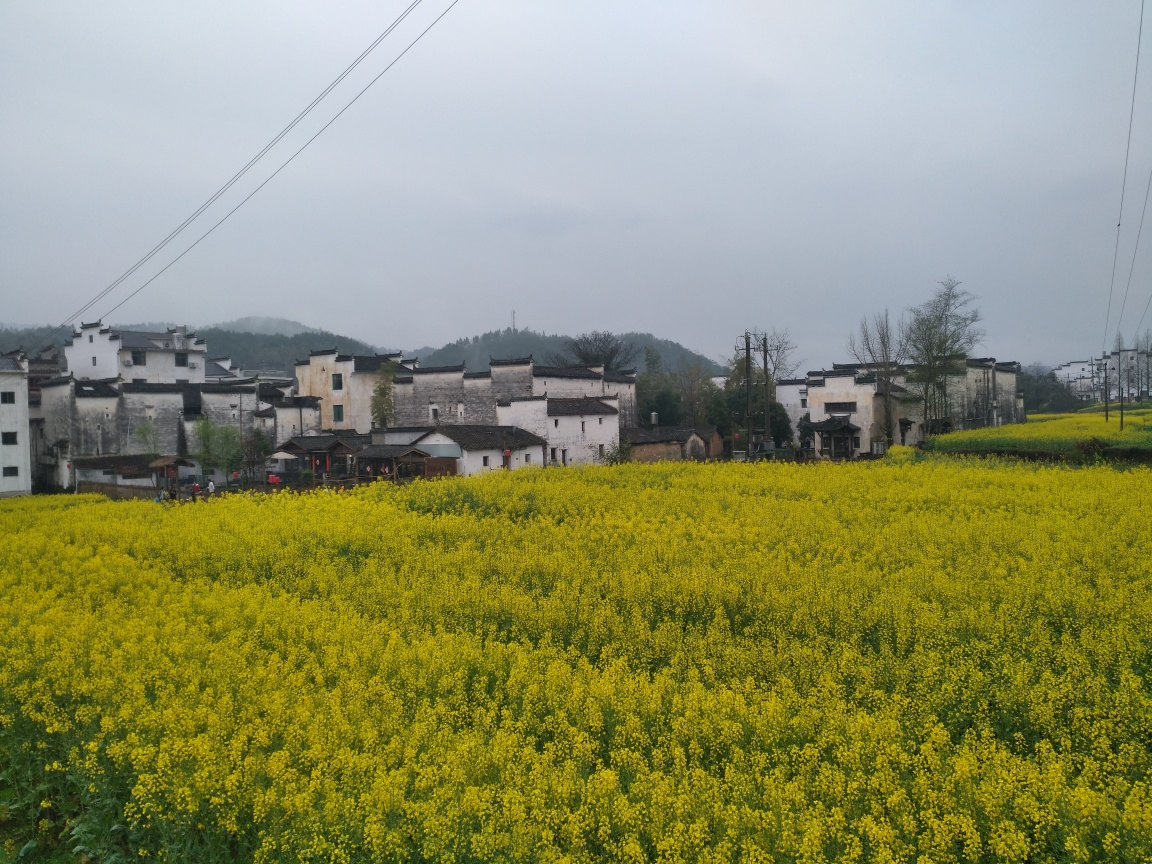Can you tell me more about the architectural style of the buildings? Certainly. The buildings depicted in the image have a traditional architectural style common in certain rural areas. They feature whitewashed walls and dark tile roofs that are typical of historical East Asian villages. These structures often are made of local materials and are designed to be functional for residential and agricultural use, featuring multi-storied layouts with balanced proportions and simple, geometric shapes. 